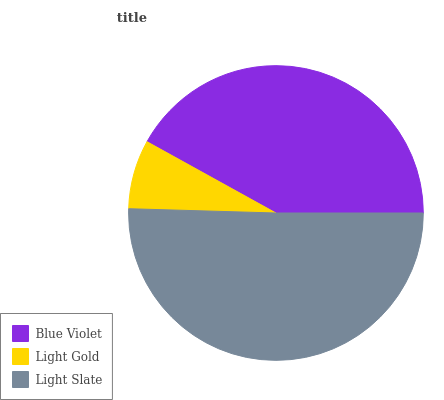Is Light Gold the minimum?
Answer yes or no. Yes. Is Light Slate the maximum?
Answer yes or no. Yes. Is Light Slate the minimum?
Answer yes or no. No. Is Light Gold the maximum?
Answer yes or no. No. Is Light Slate greater than Light Gold?
Answer yes or no. Yes. Is Light Gold less than Light Slate?
Answer yes or no. Yes. Is Light Gold greater than Light Slate?
Answer yes or no. No. Is Light Slate less than Light Gold?
Answer yes or no. No. Is Blue Violet the high median?
Answer yes or no. Yes. Is Blue Violet the low median?
Answer yes or no. Yes. Is Light Gold the high median?
Answer yes or no. No. Is Light Slate the low median?
Answer yes or no. No. 